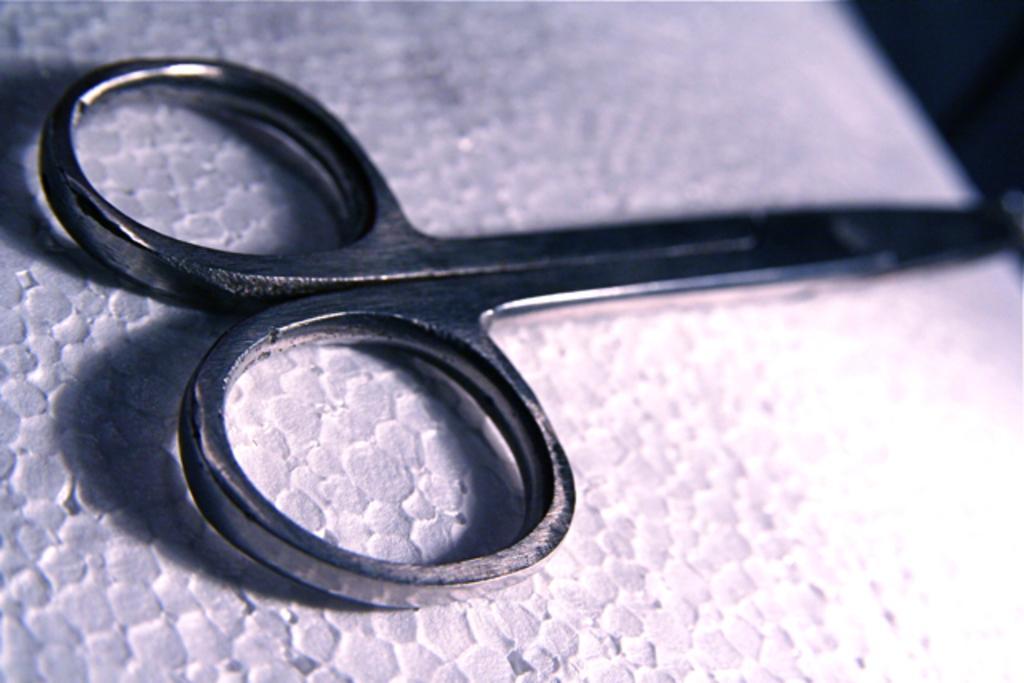How would you summarize this image in a sentence or two? In this picture we can see scissors in the front, at the bottom it looks like a paper. 